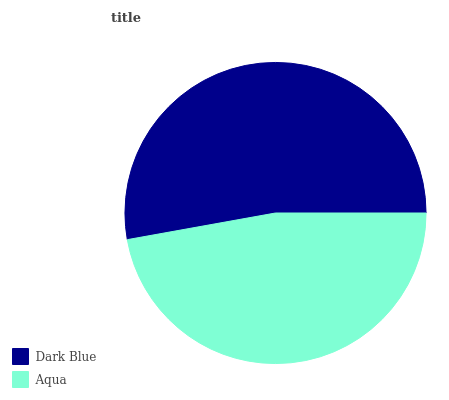Is Aqua the minimum?
Answer yes or no. Yes. Is Dark Blue the maximum?
Answer yes or no. Yes. Is Aqua the maximum?
Answer yes or no. No. Is Dark Blue greater than Aqua?
Answer yes or no. Yes. Is Aqua less than Dark Blue?
Answer yes or no. Yes. Is Aqua greater than Dark Blue?
Answer yes or no. No. Is Dark Blue less than Aqua?
Answer yes or no. No. Is Dark Blue the high median?
Answer yes or no. Yes. Is Aqua the low median?
Answer yes or no. Yes. Is Aqua the high median?
Answer yes or no. No. Is Dark Blue the low median?
Answer yes or no. No. 